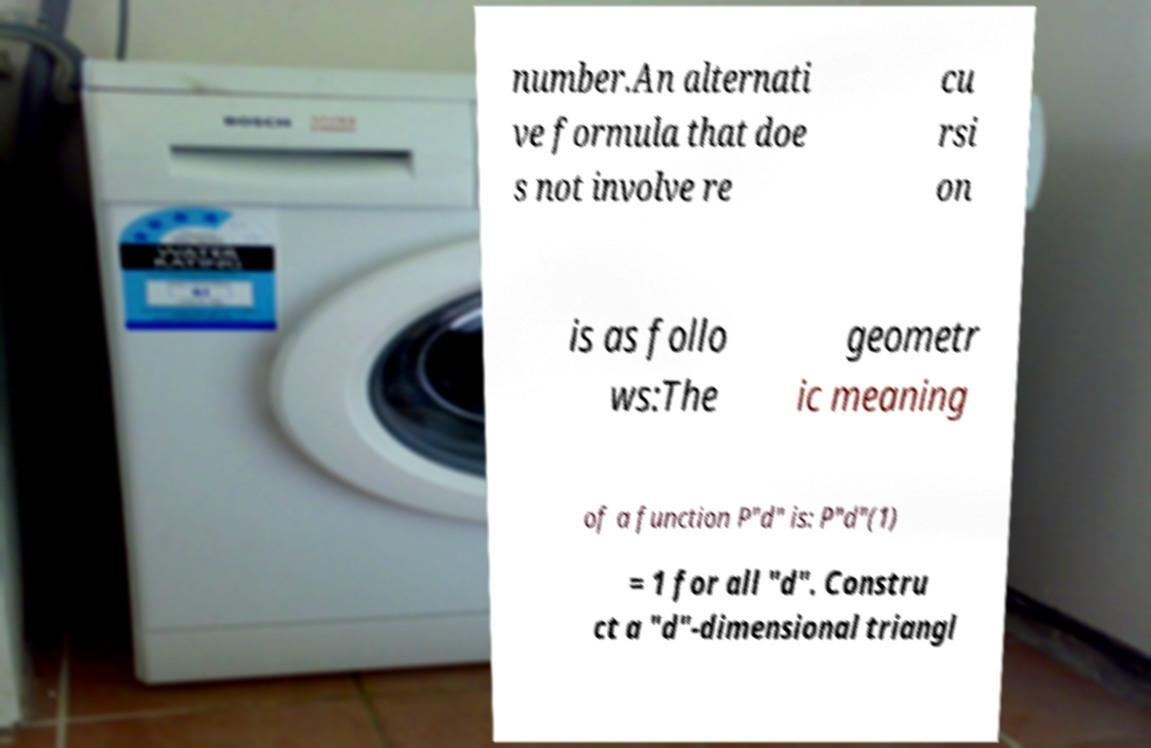Please read and relay the text visible in this image. What does it say? number.An alternati ve formula that doe s not involve re cu rsi on is as follo ws:The geometr ic meaning of a function P"d" is: P"d"(1) = 1 for all "d". Constru ct a "d"-dimensional triangl 